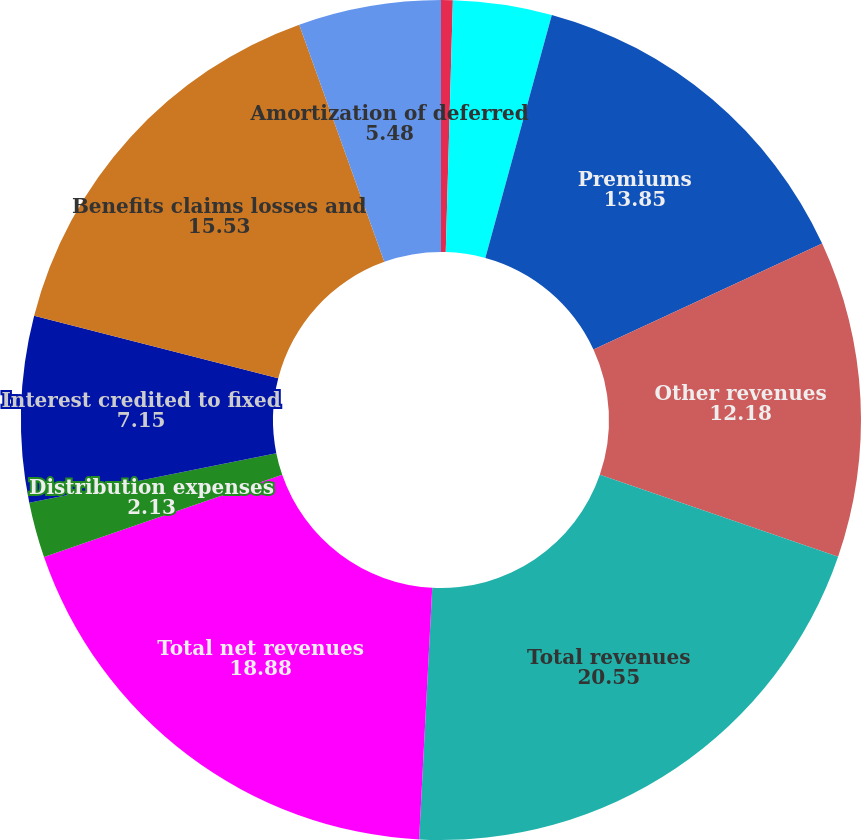Convert chart to OTSL. <chart><loc_0><loc_0><loc_500><loc_500><pie_chart><fcel>Management and financial<fcel>Distribution fees<fcel>Premiums<fcel>Other revenues<fcel>Total revenues<fcel>Total net revenues<fcel>Distribution expenses<fcel>Interest credited to fixed<fcel>Benefits claims losses and<fcel>Amortization of deferred<nl><fcel>0.45%<fcel>3.8%<fcel>13.85%<fcel>12.18%<fcel>20.55%<fcel>18.88%<fcel>2.13%<fcel>7.15%<fcel>15.53%<fcel>5.48%<nl></chart> 